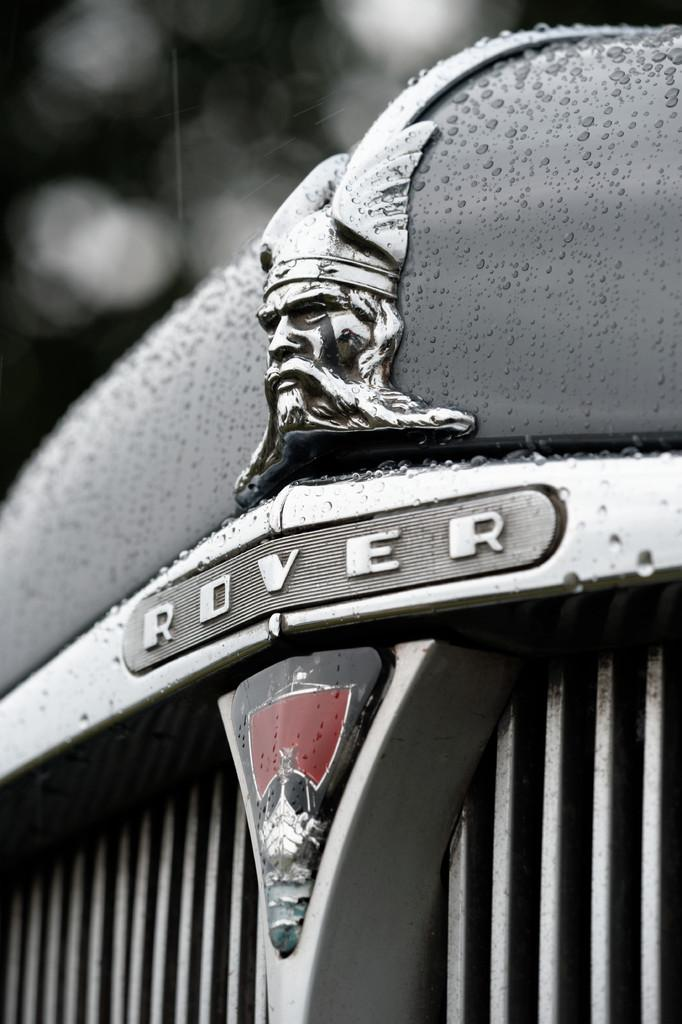What is the main subject of the image? The main subject of the image is a logo of a vehicle. Can you describe the background of the image? The background of the image is blurred. What type of addition can be seen in the image? There is no addition present in the image; it features a logo of a vehicle against a blurred background. What type of turkey can be seen in the image? There is no turkey present in the image. What type of marble is visible in the image? There is no marble present in the image. 